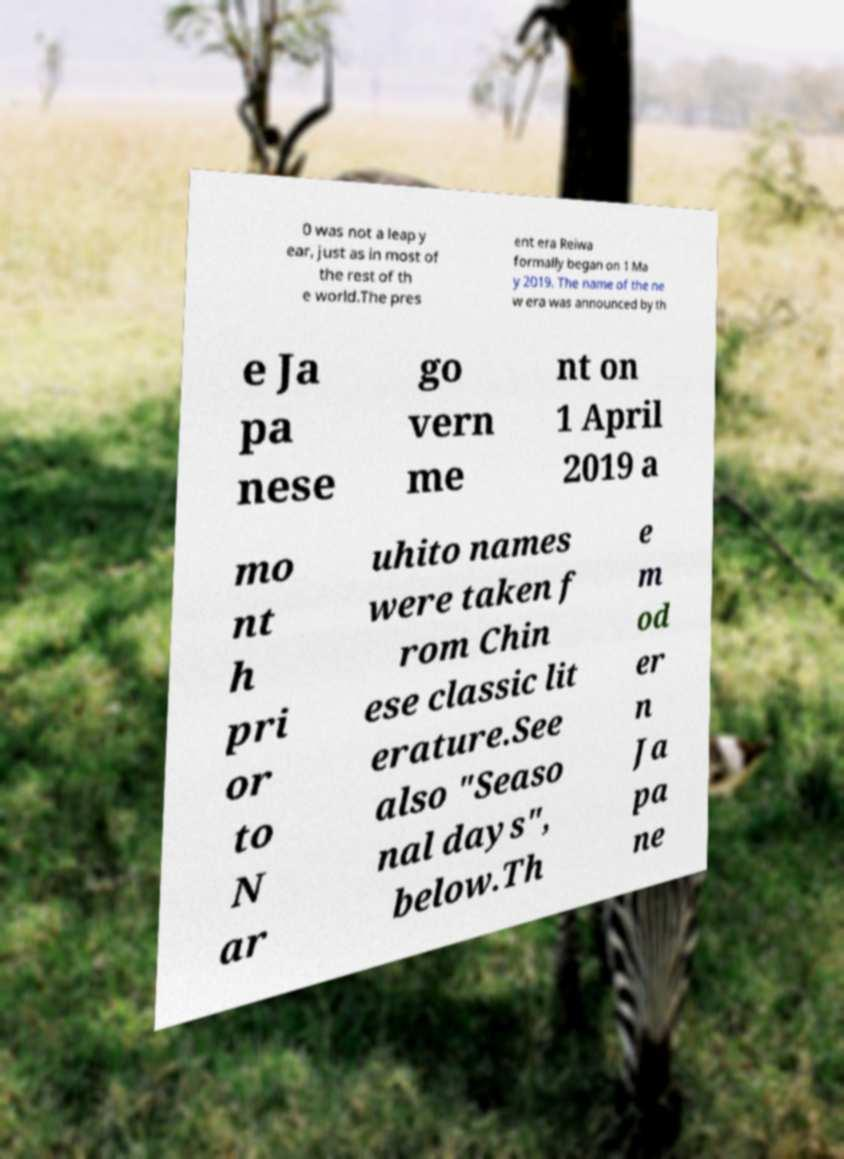Please read and relay the text visible in this image. What does it say? 0 was not a leap y ear, just as in most of the rest of th e world.The pres ent era Reiwa formally began on 1 Ma y 2019. The name of the ne w era was announced by th e Ja pa nese go vern me nt on 1 April 2019 a mo nt h pri or to N ar uhito names were taken f rom Chin ese classic lit erature.See also "Seaso nal days", below.Th e m od er n Ja pa ne 